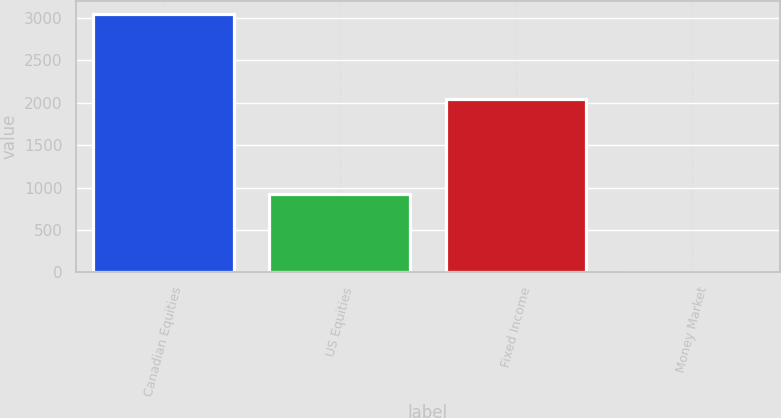<chart> <loc_0><loc_0><loc_500><loc_500><bar_chart><fcel>Canadian Equities<fcel>US Equities<fcel>Fixed Income<fcel>Money Market<nl><fcel>3050<fcel>929<fcel>2040<fcel>10<nl></chart> 